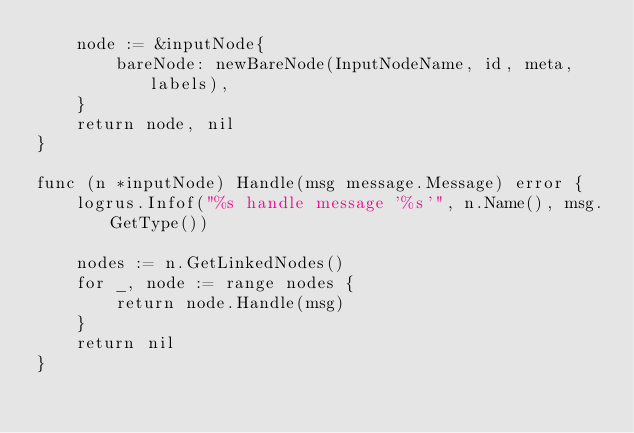<code> <loc_0><loc_0><loc_500><loc_500><_Go_>	node := &inputNode{
		bareNode: newBareNode(InputNodeName, id, meta, labels),
	}
	return node, nil
}

func (n *inputNode) Handle(msg message.Message) error {
	logrus.Infof("%s handle message '%s'", n.Name(), msg.GetType())

	nodes := n.GetLinkedNodes()
	for _, node := range nodes {
		return node.Handle(msg)
	}
	return nil
}
</code> 